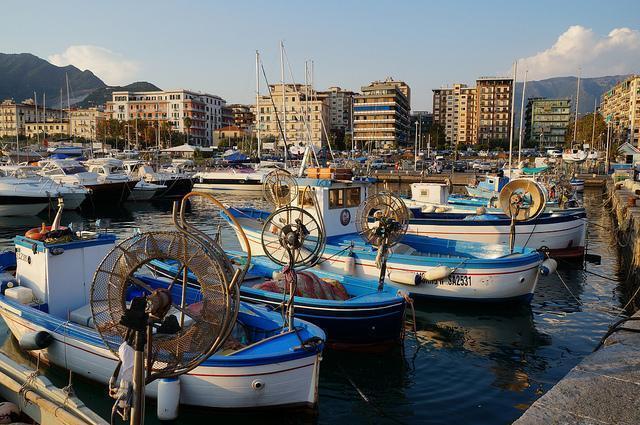What would this location be called?
Pick the correct solution from the four options below to address the question.
Options: Garage, dock, bunker, hangar. Dock. 